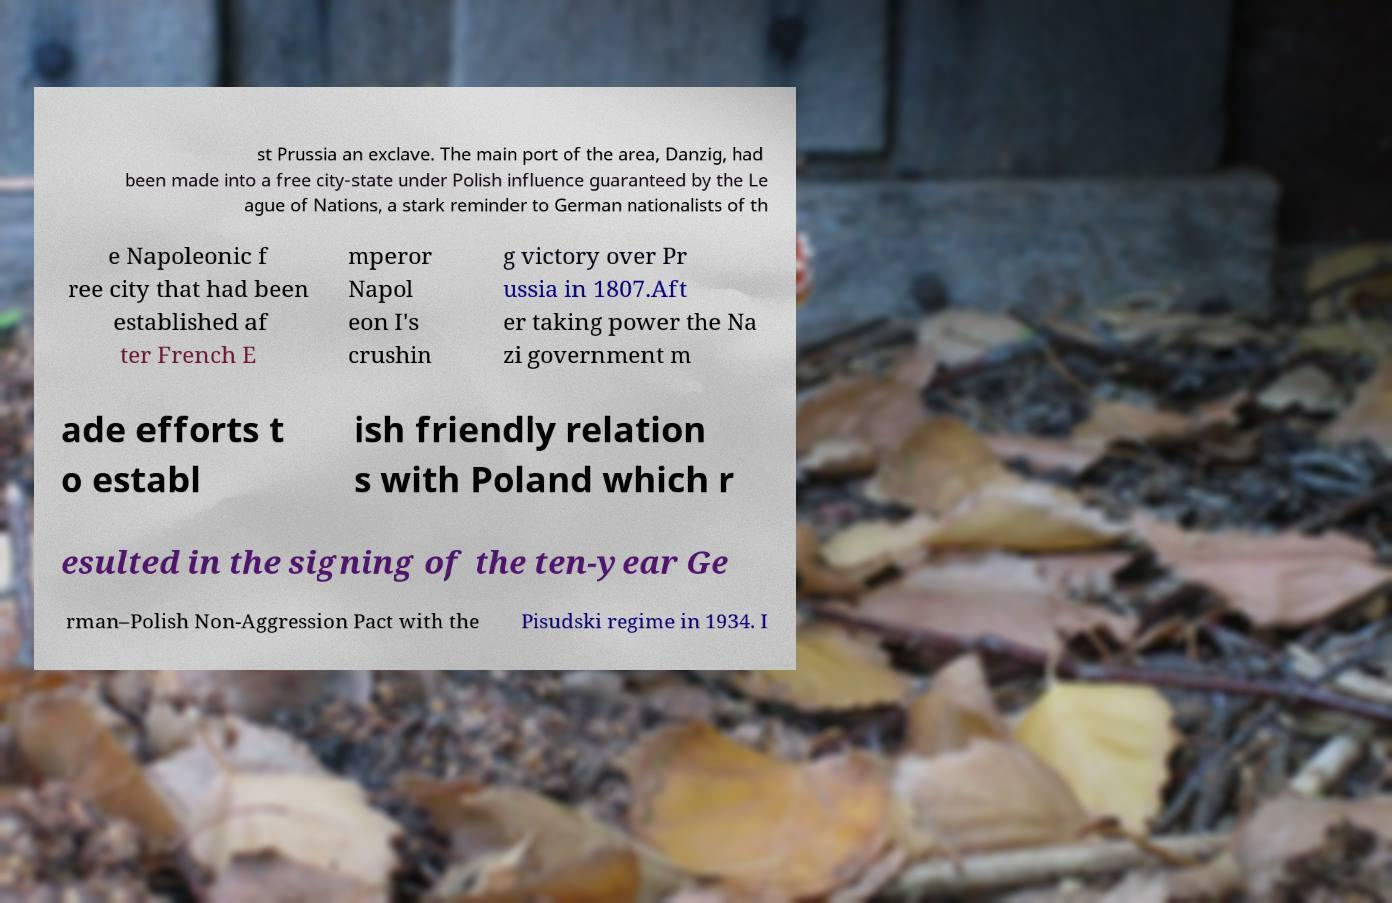What messages or text are displayed in this image? I need them in a readable, typed format. st Prussia an exclave. The main port of the area, Danzig, had been made into a free city-state under Polish influence guaranteed by the Le ague of Nations, a stark reminder to German nationalists of th e Napoleonic f ree city that had been established af ter French E mperor Napol eon I's crushin g victory over Pr ussia in 1807.Aft er taking power the Na zi government m ade efforts t o establ ish friendly relation s with Poland which r esulted in the signing of the ten-year Ge rman–Polish Non-Aggression Pact with the Pisudski regime in 1934. I 